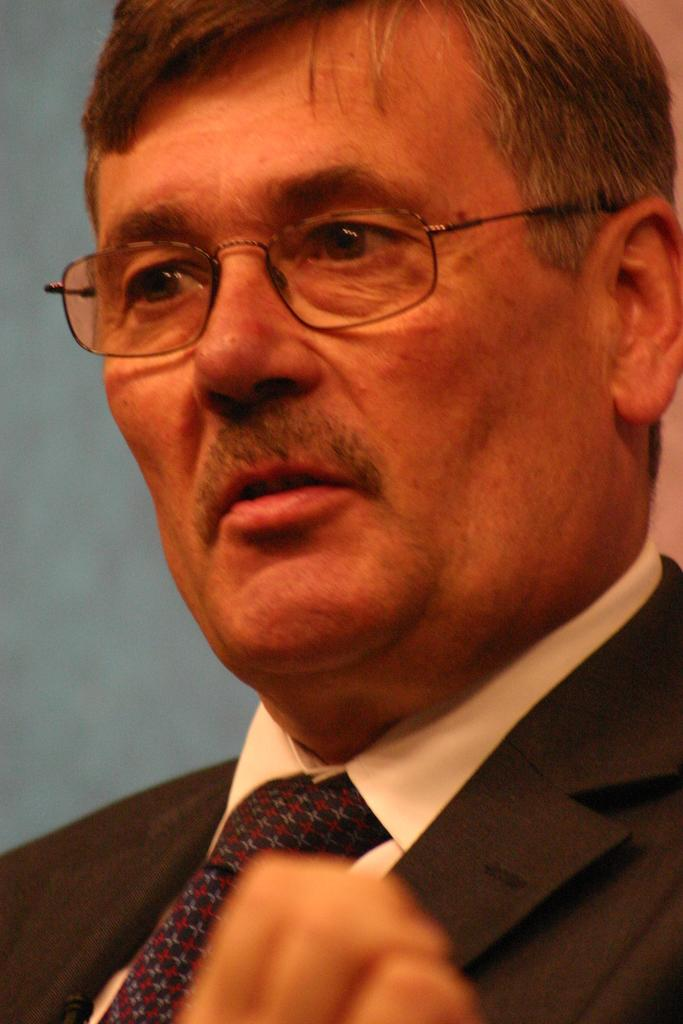What is the main subject of the image? The main subject of the image is a man. What is the man wearing on his upper body? The man is wearing a white shirt and a black coat. What accessory is the man wearing around his neck? The man is wearing a black tie. What type of eyewear is the man wearing? The man is wearing specks. What type of loaf is the man holding in the image? There is no loaf present in the image. What type of honey can be seen dripping from the man's tie in the image? There is no honey present in the image. 